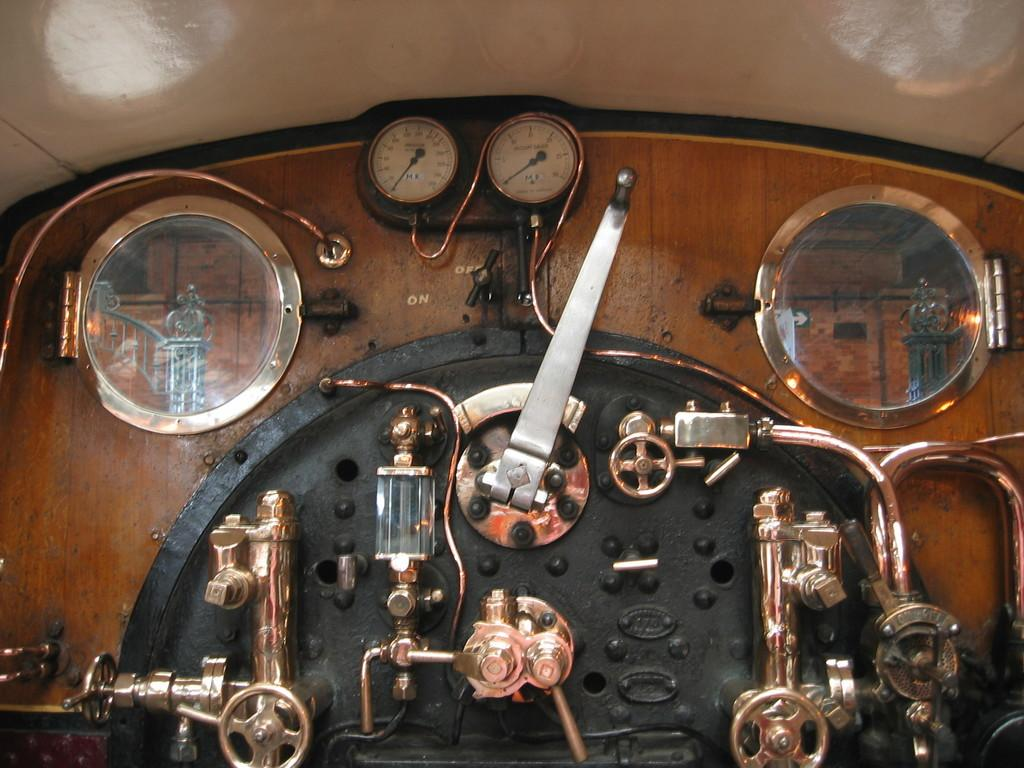What is the main subject of the image? The main subject of the image is a machine. Can you describe the setting of the image? There is a roof visible at the top of the image, which suggests that the machine might be located indoors. How many babies are crawling around the machine in the image? There are no babies present in the image; it only features a machine and a roof. 